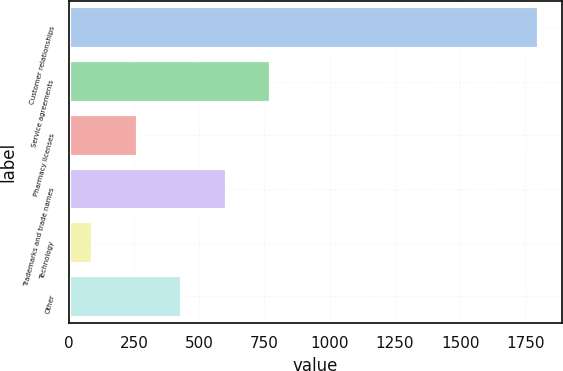Convert chart. <chart><loc_0><loc_0><loc_500><loc_500><bar_chart><fcel>Customer relationships<fcel>Service agreements<fcel>Pharmacy licenses<fcel>Trademarks and trade names<fcel>Technology<fcel>Other<nl><fcel>1801<fcel>776.8<fcel>264.7<fcel>606.1<fcel>94<fcel>435.4<nl></chart> 